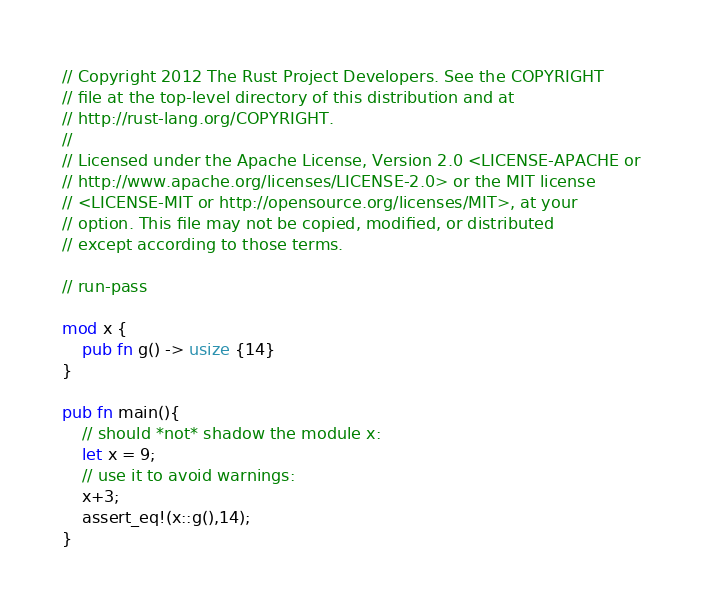<code> <loc_0><loc_0><loc_500><loc_500><_Rust_>// Copyright 2012 The Rust Project Developers. See the COPYRIGHT
// file at the top-level directory of this distribution and at
// http://rust-lang.org/COPYRIGHT.
//
// Licensed under the Apache License, Version 2.0 <LICENSE-APACHE or
// http://www.apache.org/licenses/LICENSE-2.0> or the MIT license
// <LICENSE-MIT or http://opensource.org/licenses/MIT>, at your
// option. This file may not be copied, modified, or distributed
// except according to those terms.

// run-pass

mod x {
    pub fn g() -> usize {14}
}

pub fn main(){
    // should *not* shadow the module x:
    let x = 9;
    // use it to avoid warnings:
    x+3;
    assert_eq!(x::g(),14);
}
</code> 